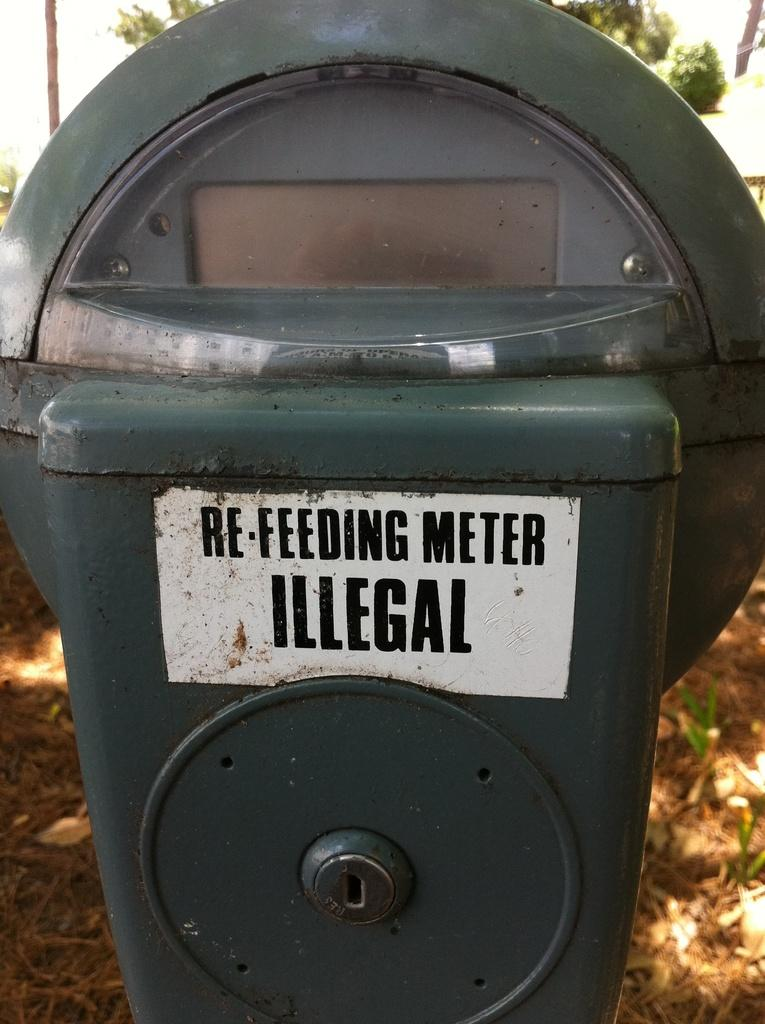What is the main object in the image? There is a refereeing meter in the image. Where is the refereeing meter located? The refereeing meter is placed on a surface. What other objects can be seen in the image? There is a pole and a tree in the image. How many cherries are hanging from the pole in the image? There are no cherries present in the image; the pole is not associated with any cherries. 